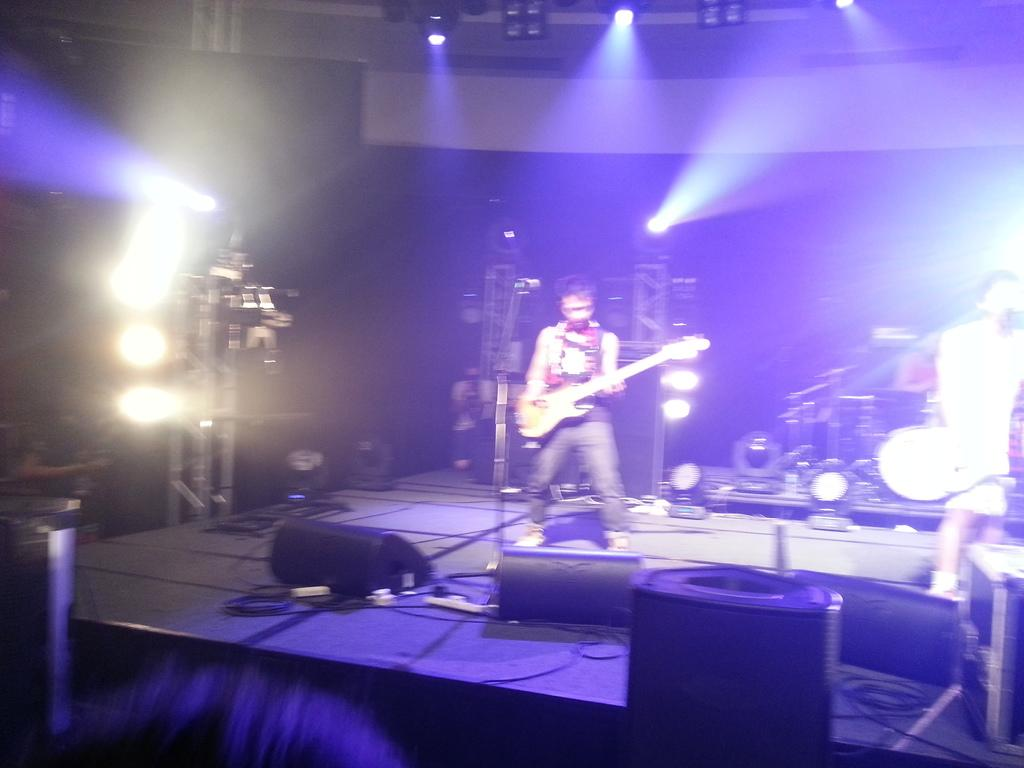How many people are in the image? There are two men in the image. Where are the men located in the image? The men are standing on a stage. What are the men doing in the image? The men are playing a guitar. What equipment is in front of the men? There is a microphone in front of the men. What can be seen behind the men? There is an iron pillar behind the men. What is located in front of the stage? There is a sound box in front of the stage. What type of headphones is the dad wearing in the image? There is no dad or headphones present in the image. 